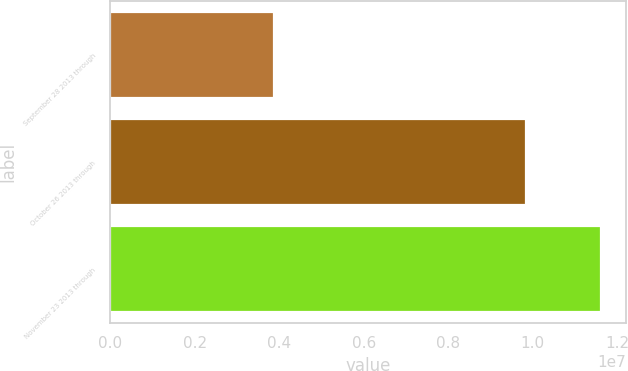Convert chart. <chart><loc_0><loc_0><loc_500><loc_500><bar_chart><fcel>September 28 2013 through<fcel>October 26 2013 through<fcel>November 23 2013 through<nl><fcel>3.88179e+06<fcel>9.83799e+06<fcel>1.16288e+07<nl></chart> 